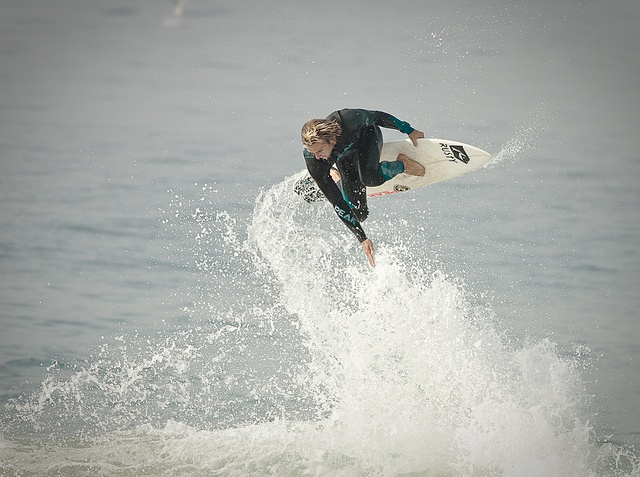Describe the objects in this image and their specific colors. I can see people in gray, black, darkgray, and lightgray tones and surfboard in gray, lightgray, darkgray, beige, and tan tones in this image. 